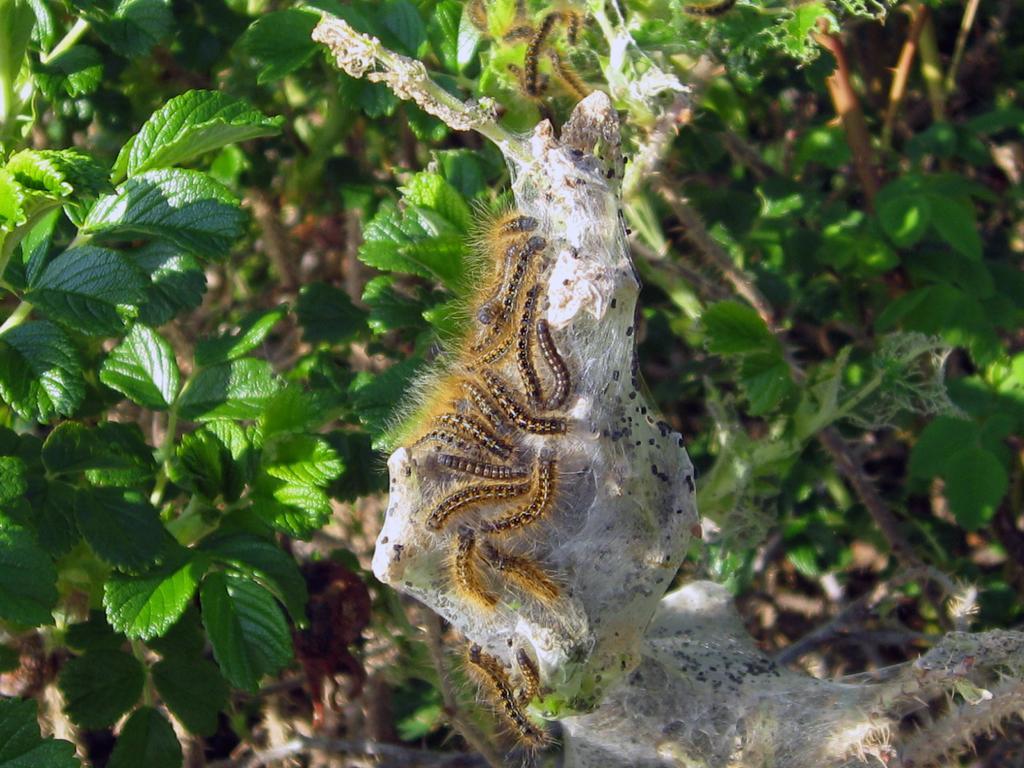In one or two sentences, can you explain what this image depicts? In the picture I can see insects on something in white color. I can also see plants in the background. 